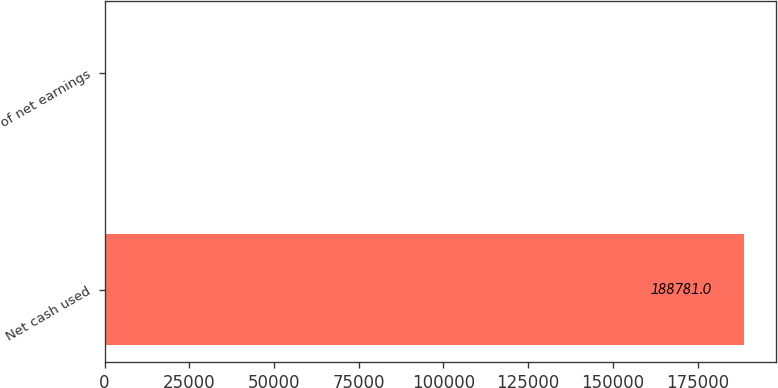<chart> <loc_0><loc_0><loc_500><loc_500><bar_chart><fcel>Net cash used<fcel>of net earnings<nl><fcel>188781<fcel>38.2<nl></chart> 